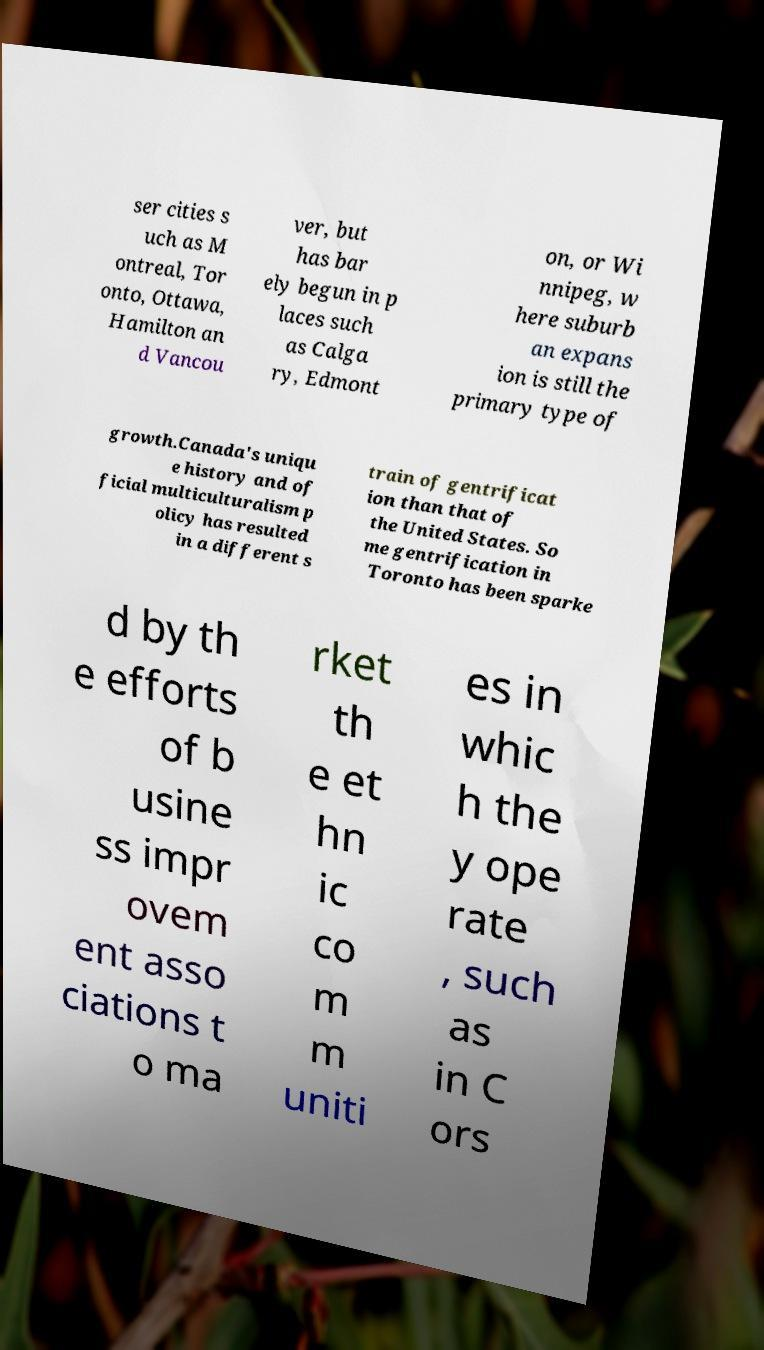Can you accurately transcribe the text from the provided image for me? ser cities s uch as M ontreal, Tor onto, Ottawa, Hamilton an d Vancou ver, but has bar ely begun in p laces such as Calga ry, Edmont on, or Wi nnipeg, w here suburb an expans ion is still the primary type of growth.Canada's uniqu e history and of ficial multiculturalism p olicy has resulted in a different s train of gentrificat ion than that of the United States. So me gentrification in Toronto has been sparke d by th e efforts of b usine ss impr ovem ent asso ciations t o ma rket th e et hn ic co m m uniti es in whic h the y ope rate , such as in C ors 